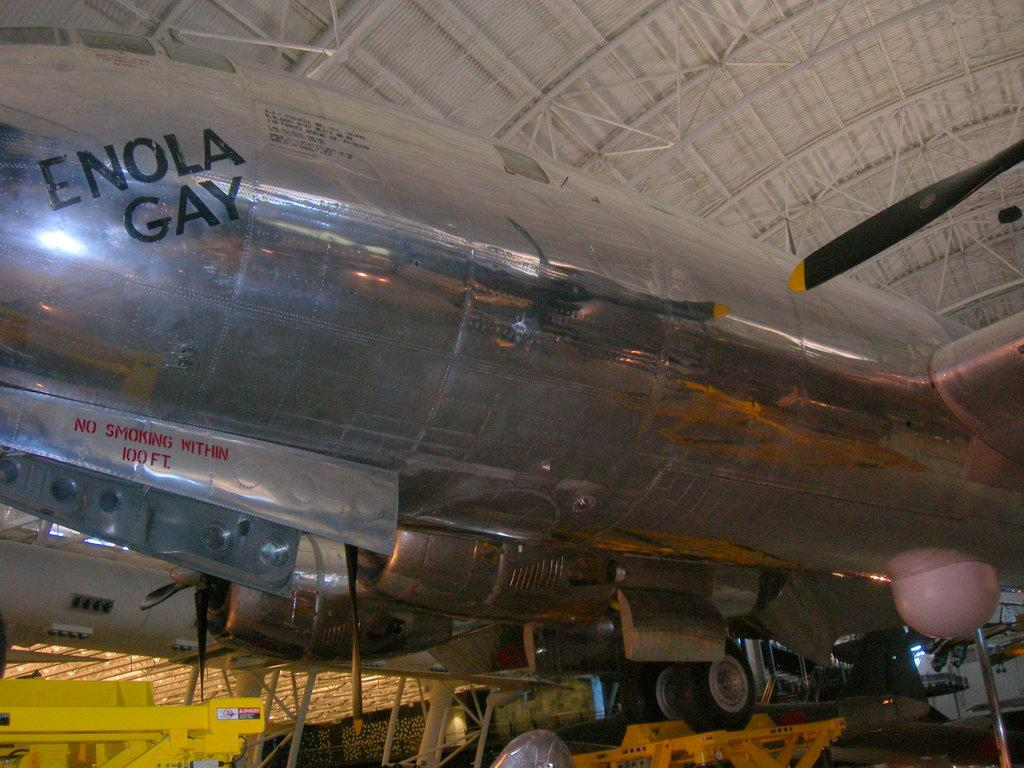Provide a one-sentence caption for the provided image. a silver plans has the words ENOLA GAy on it. 